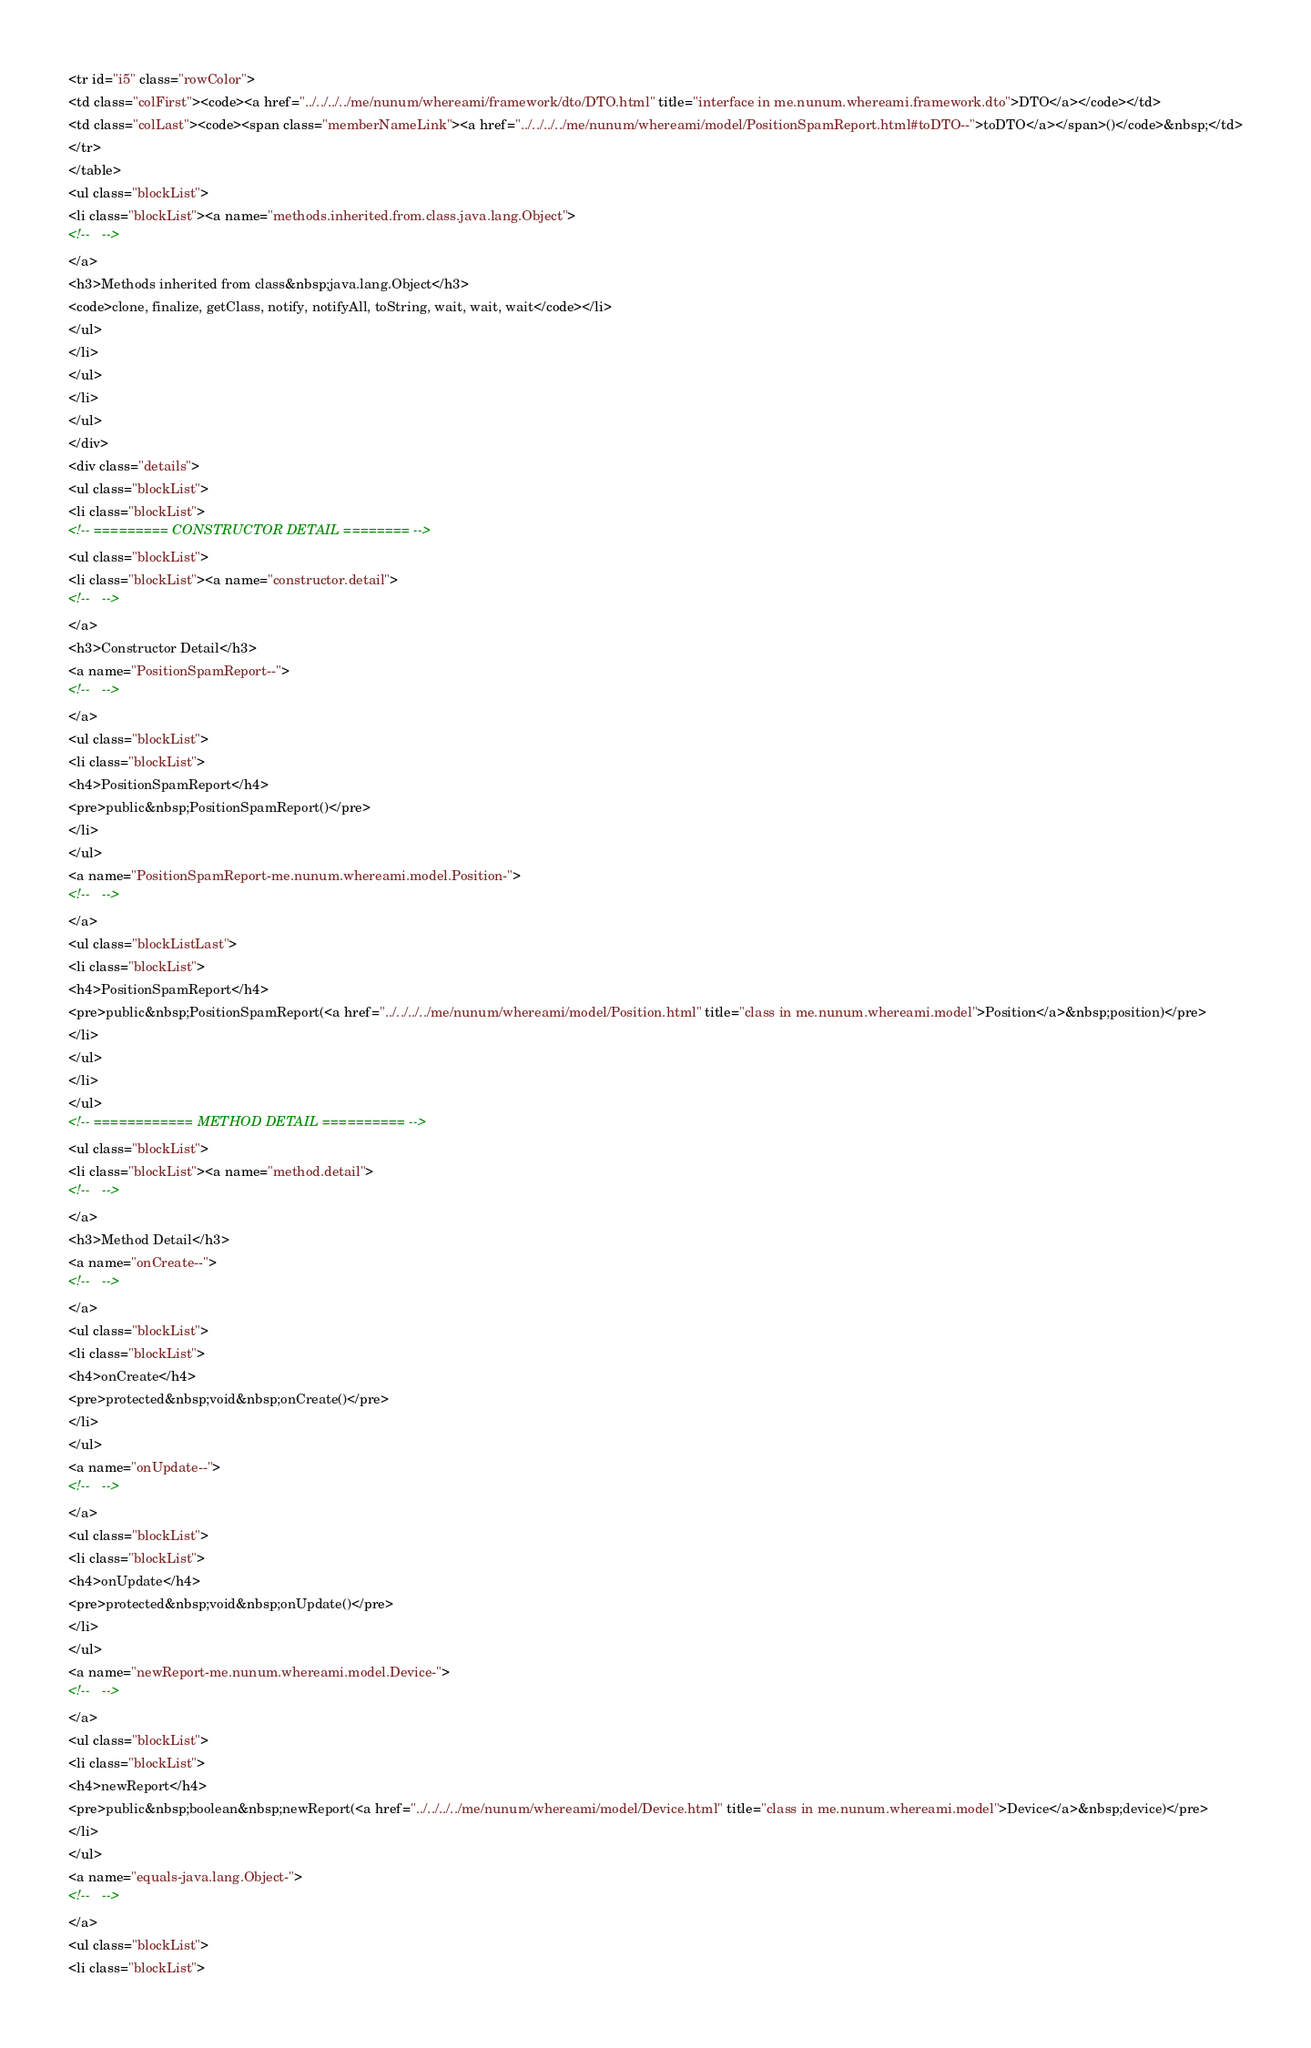Convert code to text. <code><loc_0><loc_0><loc_500><loc_500><_HTML_><tr id="i5" class="rowColor">
<td class="colFirst"><code><a href="../../../../me/nunum/whereami/framework/dto/DTO.html" title="interface in me.nunum.whereami.framework.dto">DTO</a></code></td>
<td class="colLast"><code><span class="memberNameLink"><a href="../../../../me/nunum/whereami/model/PositionSpamReport.html#toDTO--">toDTO</a></span>()</code>&nbsp;</td>
</tr>
</table>
<ul class="blockList">
<li class="blockList"><a name="methods.inherited.from.class.java.lang.Object">
<!--   -->
</a>
<h3>Methods inherited from class&nbsp;java.lang.Object</h3>
<code>clone, finalize, getClass, notify, notifyAll, toString, wait, wait, wait</code></li>
</ul>
</li>
</ul>
</li>
</ul>
</div>
<div class="details">
<ul class="blockList">
<li class="blockList">
<!-- ========= CONSTRUCTOR DETAIL ======== -->
<ul class="blockList">
<li class="blockList"><a name="constructor.detail">
<!--   -->
</a>
<h3>Constructor Detail</h3>
<a name="PositionSpamReport--">
<!--   -->
</a>
<ul class="blockList">
<li class="blockList">
<h4>PositionSpamReport</h4>
<pre>public&nbsp;PositionSpamReport()</pre>
</li>
</ul>
<a name="PositionSpamReport-me.nunum.whereami.model.Position-">
<!--   -->
</a>
<ul class="blockListLast">
<li class="blockList">
<h4>PositionSpamReport</h4>
<pre>public&nbsp;PositionSpamReport(<a href="../../../../me/nunum/whereami/model/Position.html" title="class in me.nunum.whereami.model">Position</a>&nbsp;position)</pre>
</li>
</ul>
</li>
</ul>
<!-- ============ METHOD DETAIL ========== -->
<ul class="blockList">
<li class="blockList"><a name="method.detail">
<!--   -->
</a>
<h3>Method Detail</h3>
<a name="onCreate--">
<!--   -->
</a>
<ul class="blockList">
<li class="blockList">
<h4>onCreate</h4>
<pre>protected&nbsp;void&nbsp;onCreate()</pre>
</li>
</ul>
<a name="onUpdate--">
<!--   -->
</a>
<ul class="blockList">
<li class="blockList">
<h4>onUpdate</h4>
<pre>protected&nbsp;void&nbsp;onUpdate()</pre>
</li>
</ul>
<a name="newReport-me.nunum.whereami.model.Device-">
<!--   -->
</a>
<ul class="blockList">
<li class="blockList">
<h4>newReport</h4>
<pre>public&nbsp;boolean&nbsp;newReport(<a href="../../../../me/nunum/whereami/model/Device.html" title="class in me.nunum.whereami.model">Device</a>&nbsp;device)</pre>
</li>
</ul>
<a name="equals-java.lang.Object-">
<!--   -->
</a>
<ul class="blockList">
<li class="blockList"></code> 